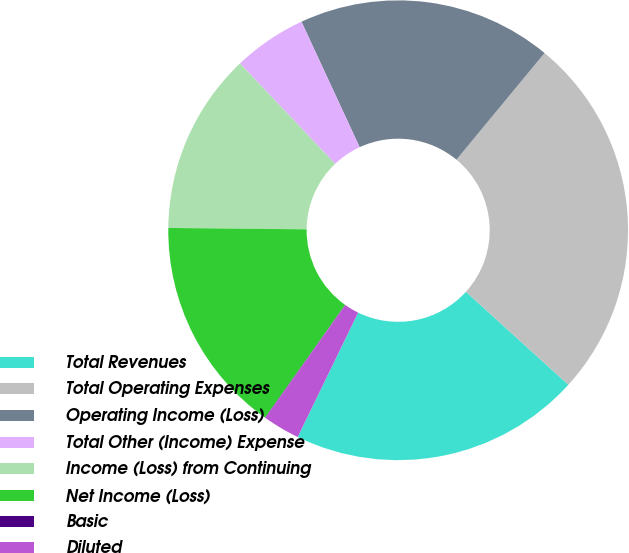Convert chart. <chart><loc_0><loc_0><loc_500><loc_500><pie_chart><fcel>Total Revenues<fcel>Total Operating Expenses<fcel>Operating Income (Loss)<fcel>Total Other (Income) Expense<fcel>Income (Loss) from Continuing<fcel>Net Income (Loss)<fcel>Basic<fcel>Diluted<nl><fcel>20.47%<fcel>25.74%<fcel>17.9%<fcel>5.17%<fcel>12.76%<fcel>15.33%<fcel>0.03%<fcel>2.6%<nl></chart> 